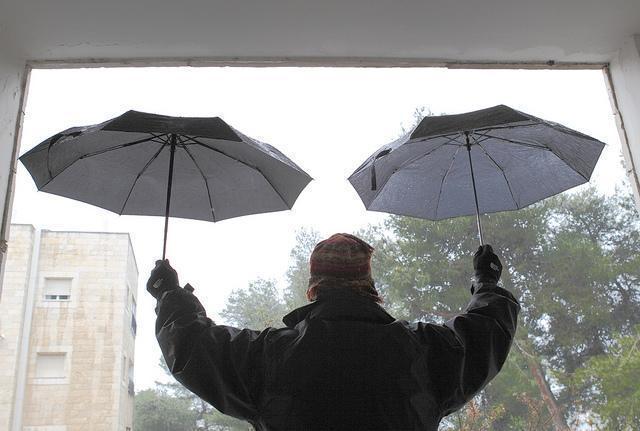What weather is being encountered here?
Choose the right answer from the provided options to respond to the question.
Options: Rain, snow, sun, sleet. Rain. Why does the man hold 2 umbrellas?
From the following set of four choices, select the accurate answer to respond to the question.
Options: Sun protection, confusion, photograph pose, snow prevention. Photograph pose. 